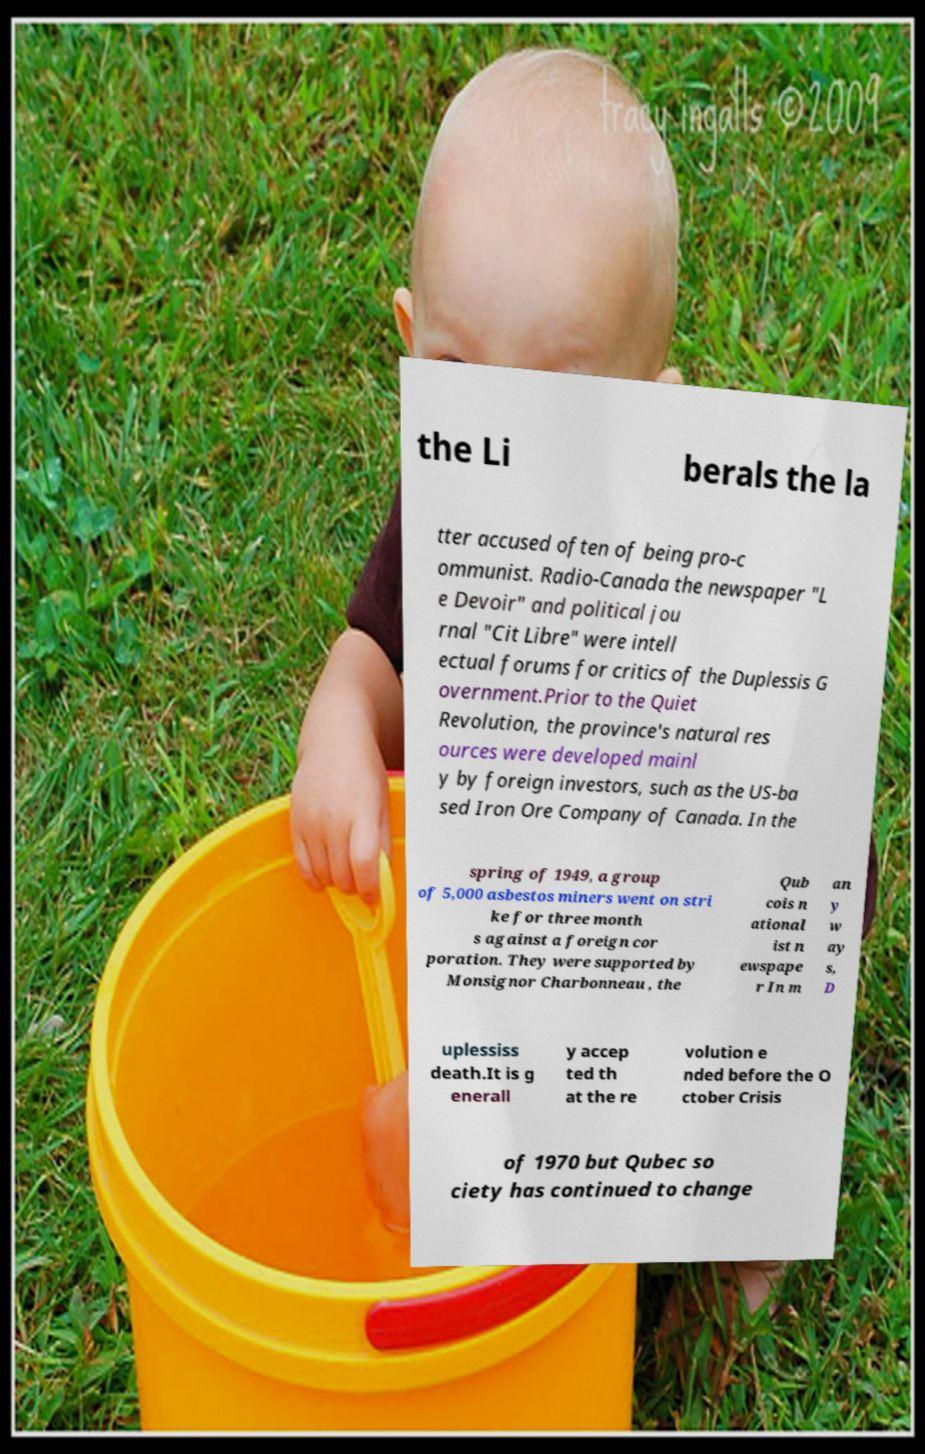Could you extract and type out the text from this image? the Li berals the la tter accused often of being pro-c ommunist. Radio-Canada the newspaper "L e Devoir" and political jou rnal "Cit Libre" were intell ectual forums for critics of the Duplessis G overnment.Prior to the Quiet Revolution, the province's natural res ources were developed mainl y by foreign investors, such as the US-ba sed Iron Ore Company of Canada. In the spring of 1949, a group of 5,000 asbestos miners went on stri ke for three month s against a foreign cor poration. They were supported by Monsignor Charbonneau , the Qub cois n ational ist n ewspape r In m an y w ay s, D uplessiss death.It is g enerall y accep ted th at the re volution e nded before the O ctober Crisis of 1970 but Qubec so ciety has continued to change 